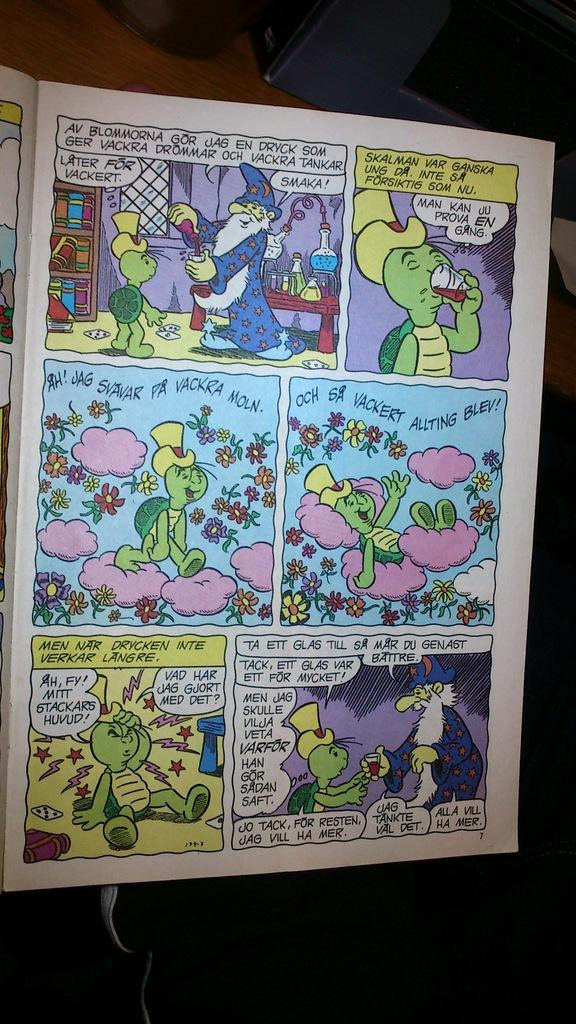<image>
Write a terse but informative summary of the picture. A comic book has the words Later for Vackert on it. 